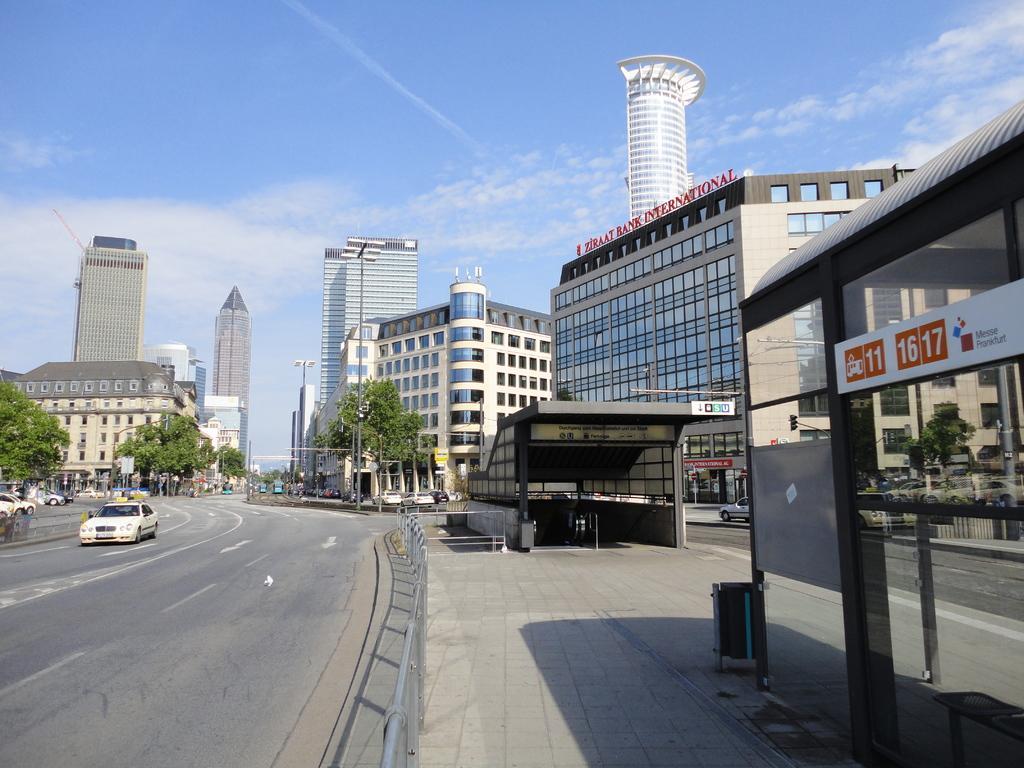Can you describe this image briefly? In this image we can see few buildings, trees, light poles, few vehicles on the road, railings, sheds, an object on the pavement and the sky with clouds in the background. 